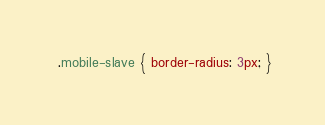Convert code to text. <code><loc_0><loc_0><loc_500><loc_500><_CSS_>
 .mobile-slave { border-radius: 3px; }</code> 